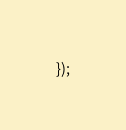<code> <loc_0><loc_0><loc_500><loc_500><_JavaScript_>});
</code> 